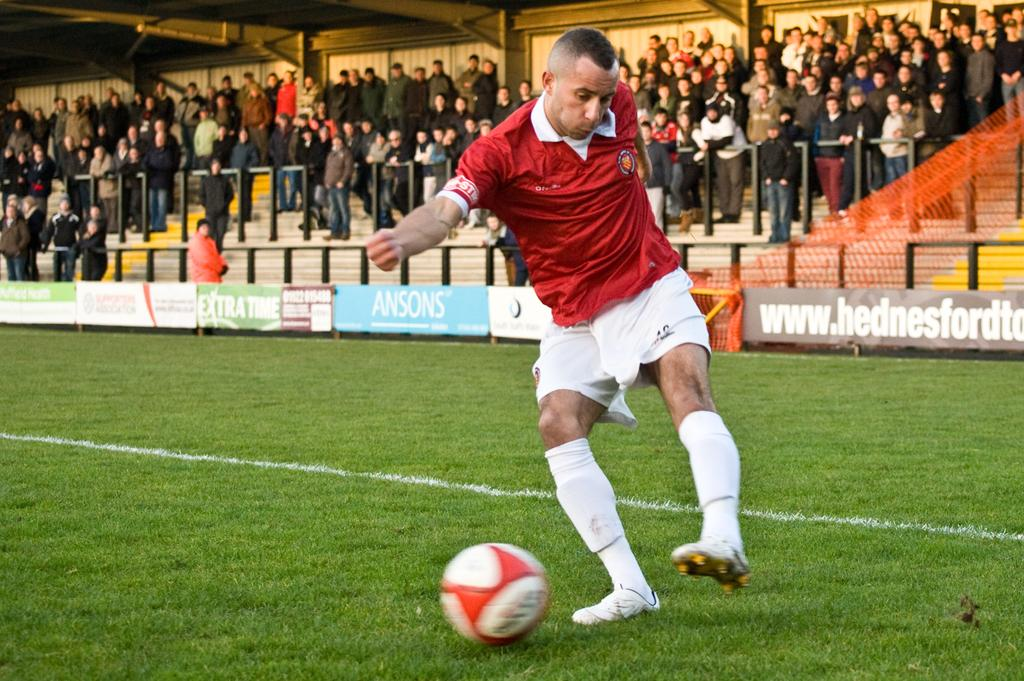Provide a one-sentence caption for the provided image. Soccer player kicking a ball in front of an ad for ANSONS. 